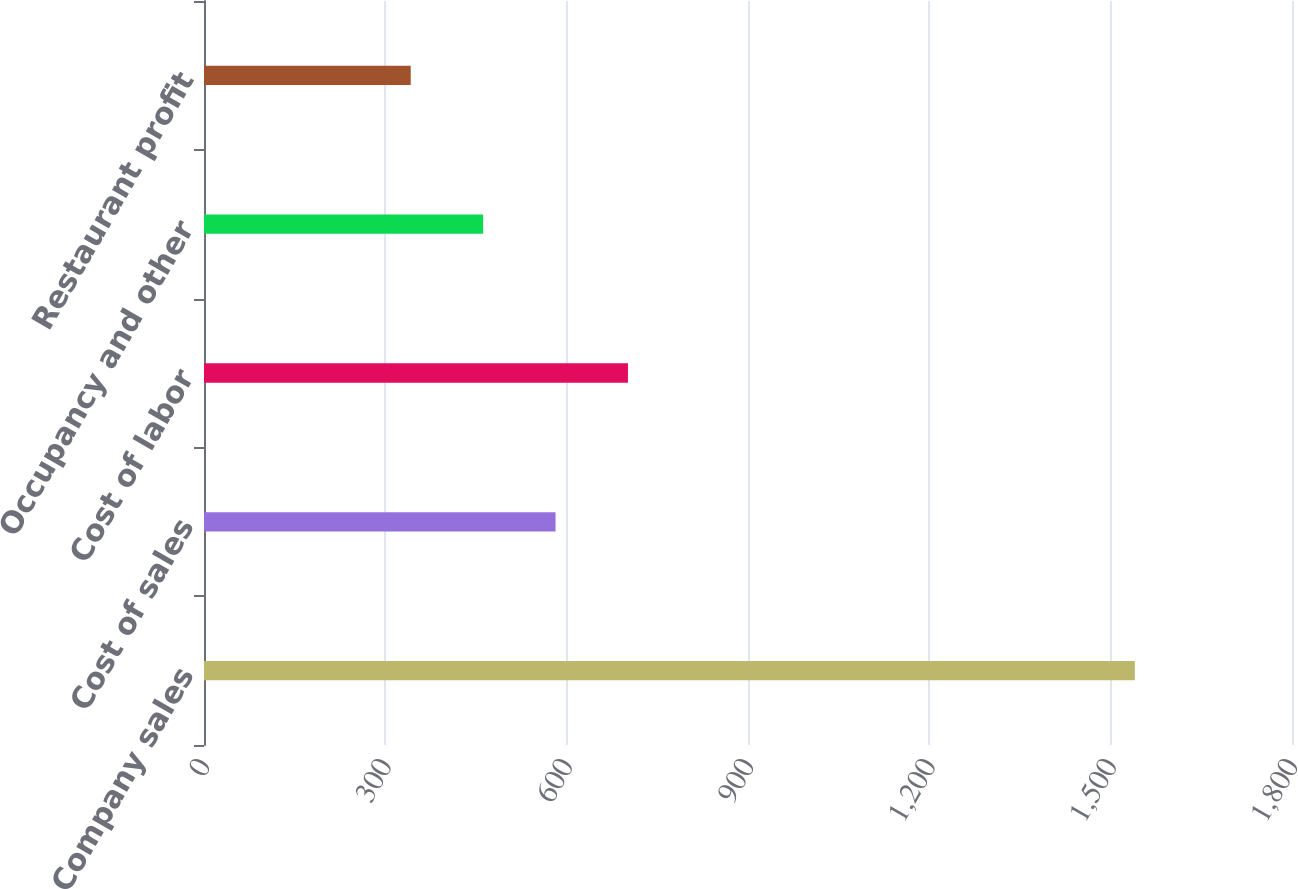Convert chart to OTSL. <chart><loc_0><loc_0><loc_500><loc_500><bar_chart><fcel>Company sales<fcel>Cost of sales<fcel>Cost of labor<fcel>Occupancy and other<fcel>Restaurant profit<nl><fcel>1540<fcel>581.6<fcel>701.4<fcel>461.8<fcel>342<nl></chart> 